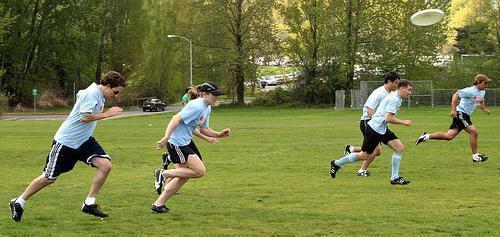How many people are seen playing?
Give a very brief answer. 6. How many frisbees are there?
Give a very brief answer. 1. 